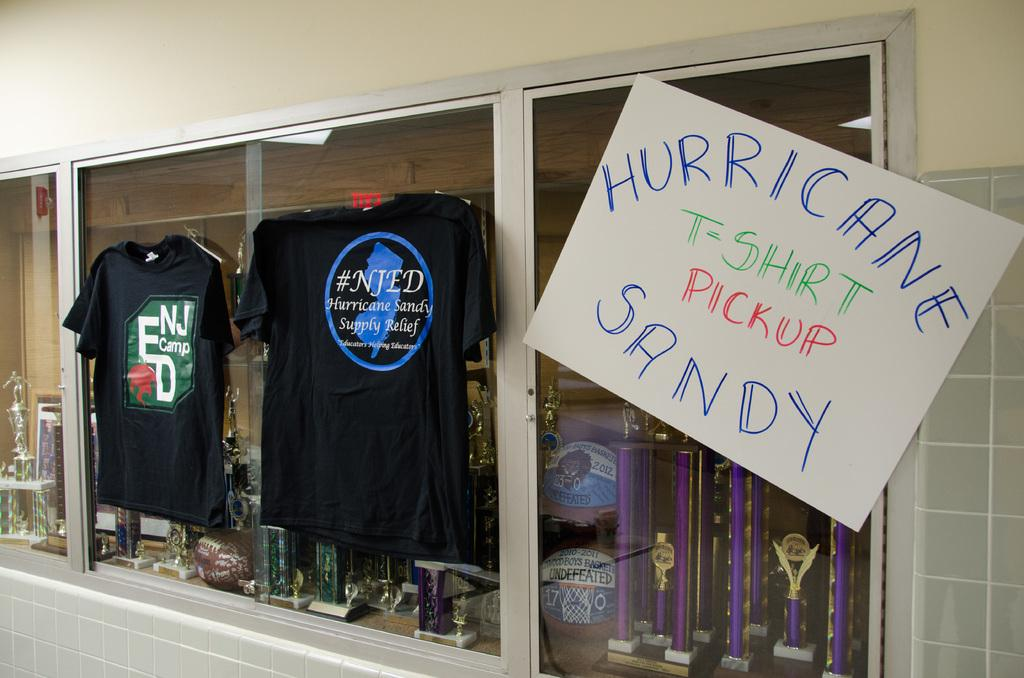<image>
Present a compact description of the photo's key features. Trophy display with a sign on it that says t-shirt pickup for Hurricane Sandy. 